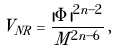Convert formula to latex. <formula><loc_0><loc_0><loc_500><loc_500>V _ { N R } = \frac { | \Phi | ^ { 2 n - 2 } } { M ^ { 2 n - 6 } } \, ,</formula> 